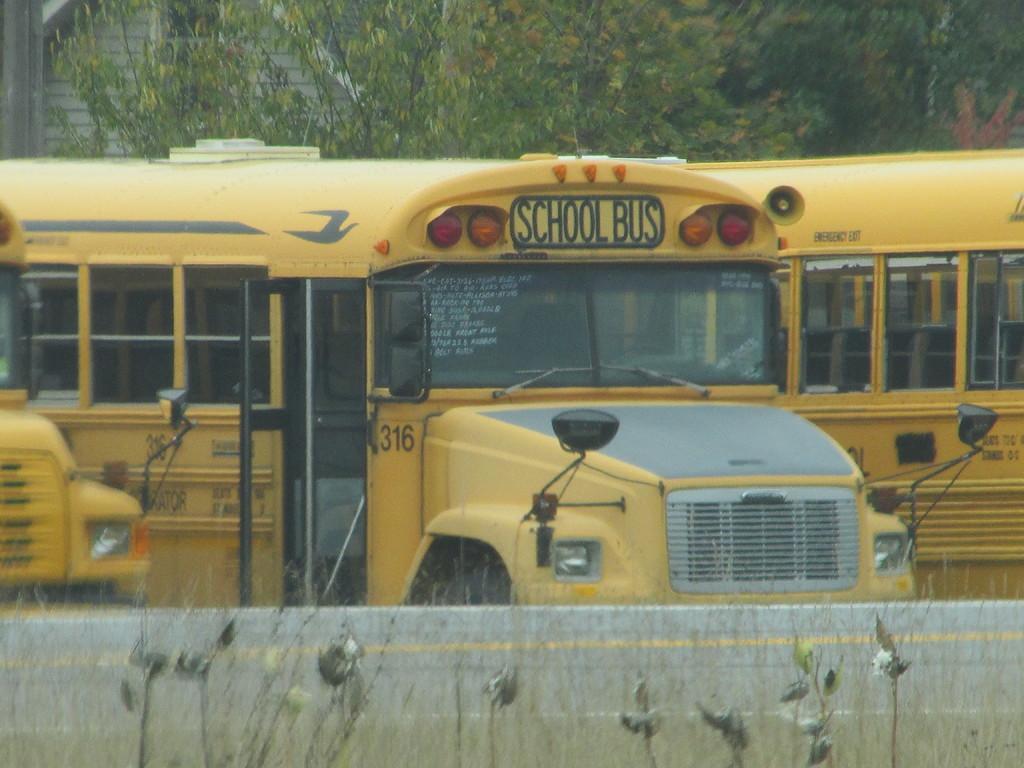How would you summarize this image in a sentence or two? This image consists of school buses in yellow color. At the bottom, we can see planets and a wall. In the background, there are trees. 